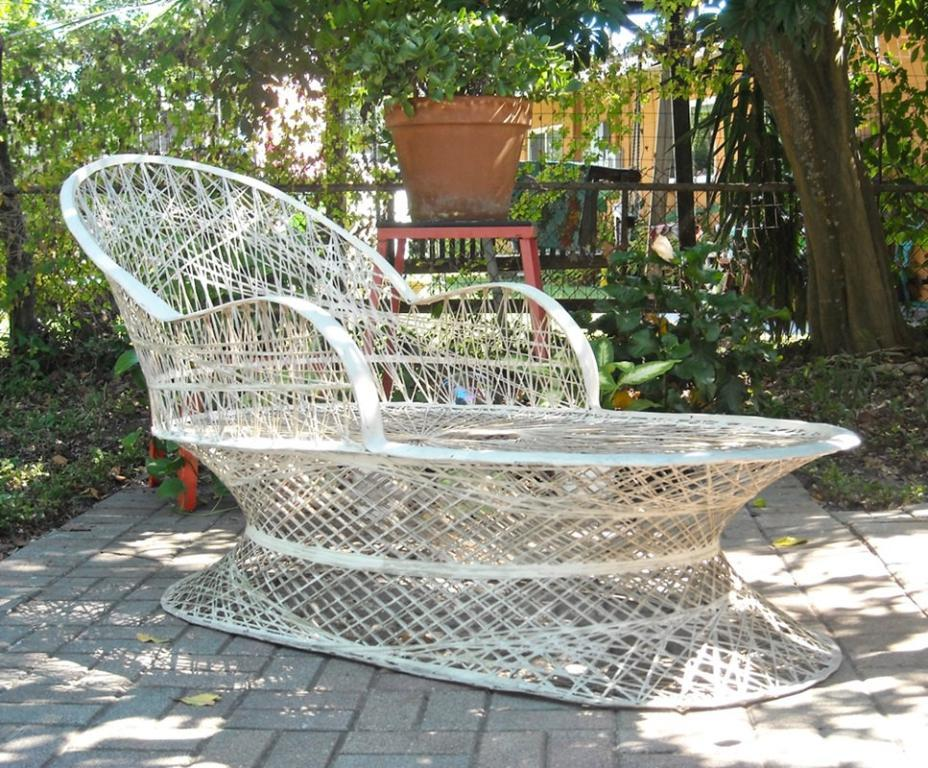What type of furniture is present in the image? There is a chair in the image. What type of natural environment is visible in the image? There is grass visible in the image. What type of container is present in the image? There is a plant pot in the image. What type of material is present in the image? There is a mesh in the image. What type of natural object is present in the image? There is a tree trunk in the image. What type of structure is present in the image? It appears that there is a house in the image. What type of plastic item can be seen in the image? There is no plastic item present in the image. What type of tool is being used to adjust the neck in the image? There is no tool or neck present in the image. 